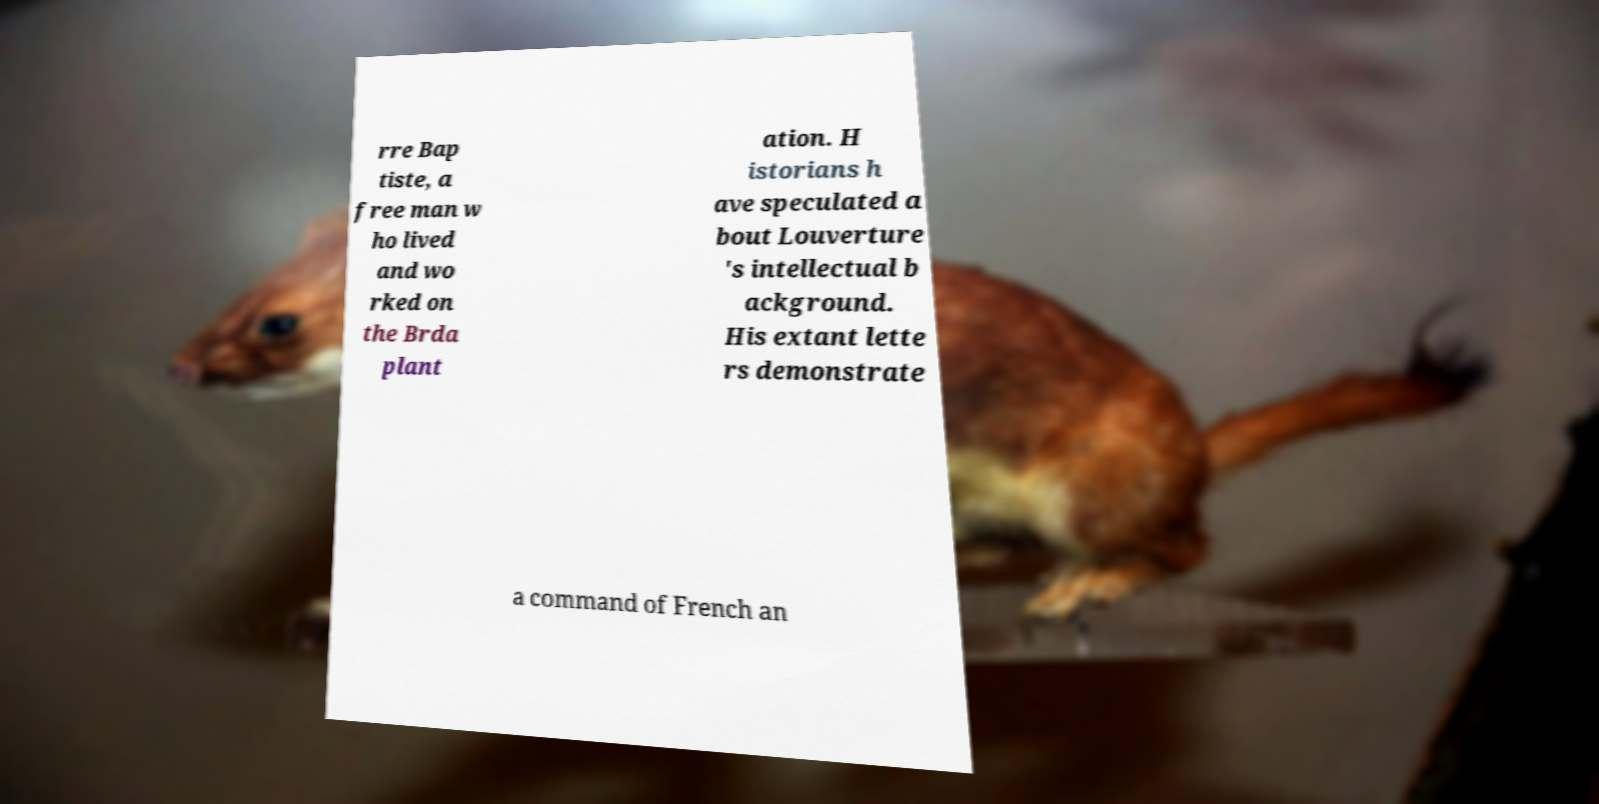Could you assist in decoding the text presented in this image and type it out clearly? rre Bap tiste, a free man w ho lived and wo rked on the Brda plant ation. H istorians h ave speculated a bout Louverture 's intellectual b ackground. His extant lette rs demonstrate a command of French an 